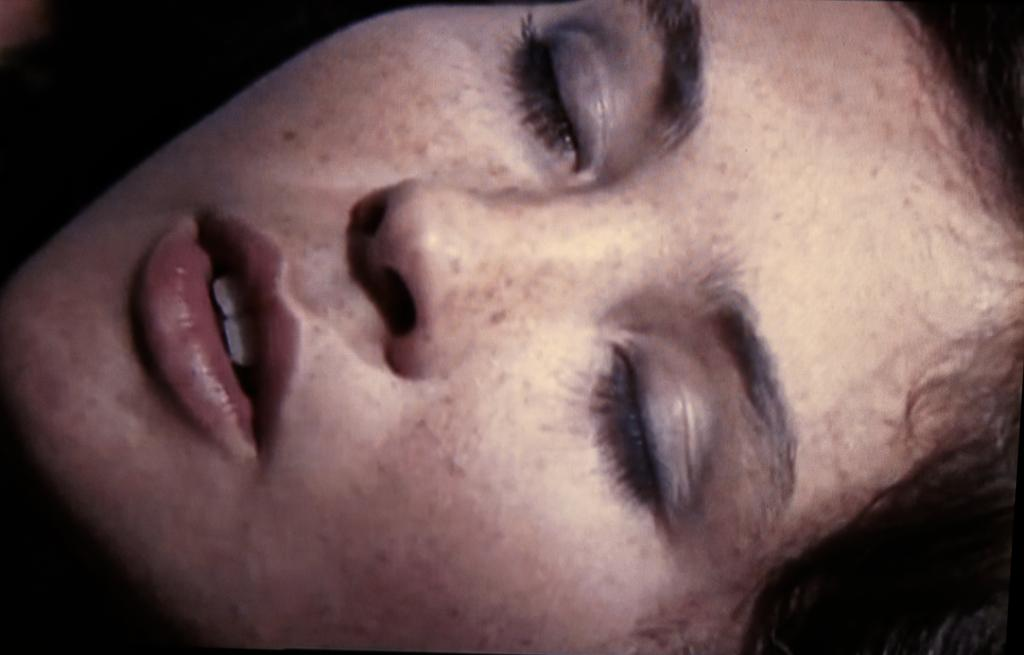What is the main subject of the image? The main subject of the image is a person's face. What can be observed about the person's eyes in the image? The person's eyes are closed in the image. What type of marble is being used to build the team's stadium in the image? There is no reference to a stadium or team in the image, and therefore no marble can be observed. 